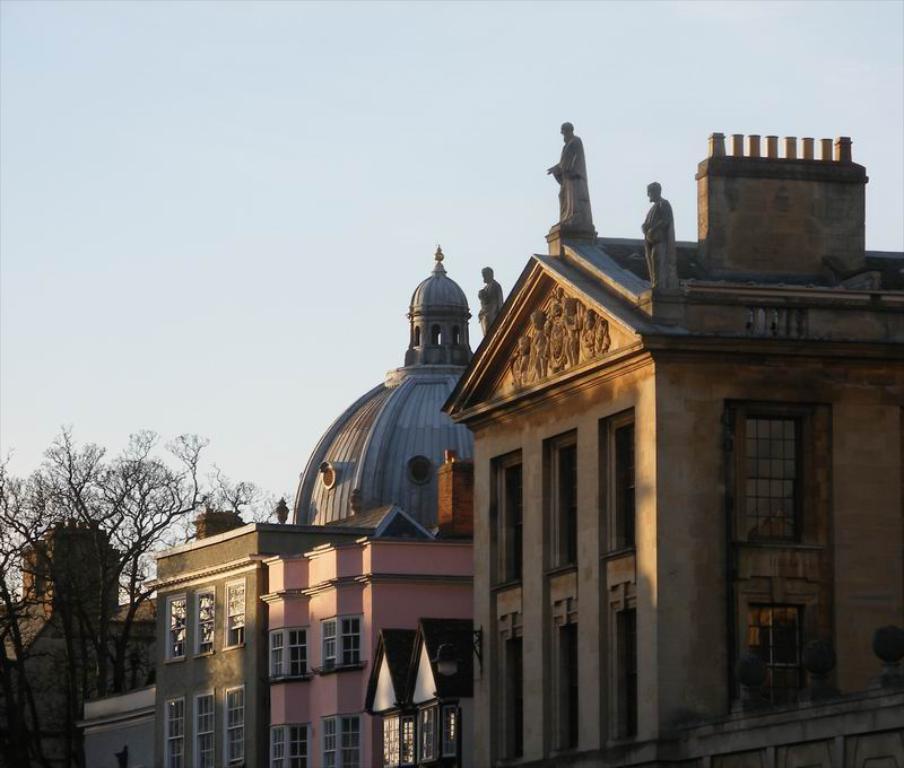Could you give a brief overview of what you see in this image? Here in this picture we can see buildings and houses present over there and in the front we can see statues present on the building over there and on the left side we can see trees present all over there. 